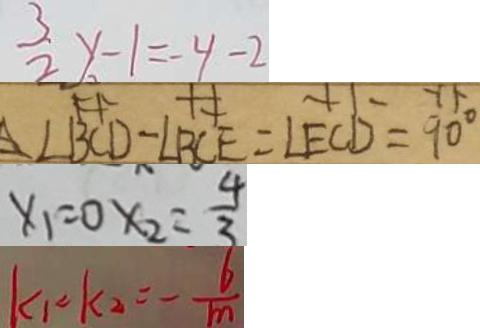Convert formula to latex. <formula><loc_0><loc_0><loc_500><loc_500>\frac { 3 } { 2 } y - 1 = - 4 - 2 
 \angle B C D - \angle B C E = \angle E C D = 9 0 ^ { \circ } 
 x _ { 1 } = 0 x _ { 2 } = \frac { 4 } { 3 } 
 k _ { 1 } = k _ { 2 } = - \frac { 6 } { m }</formula> 